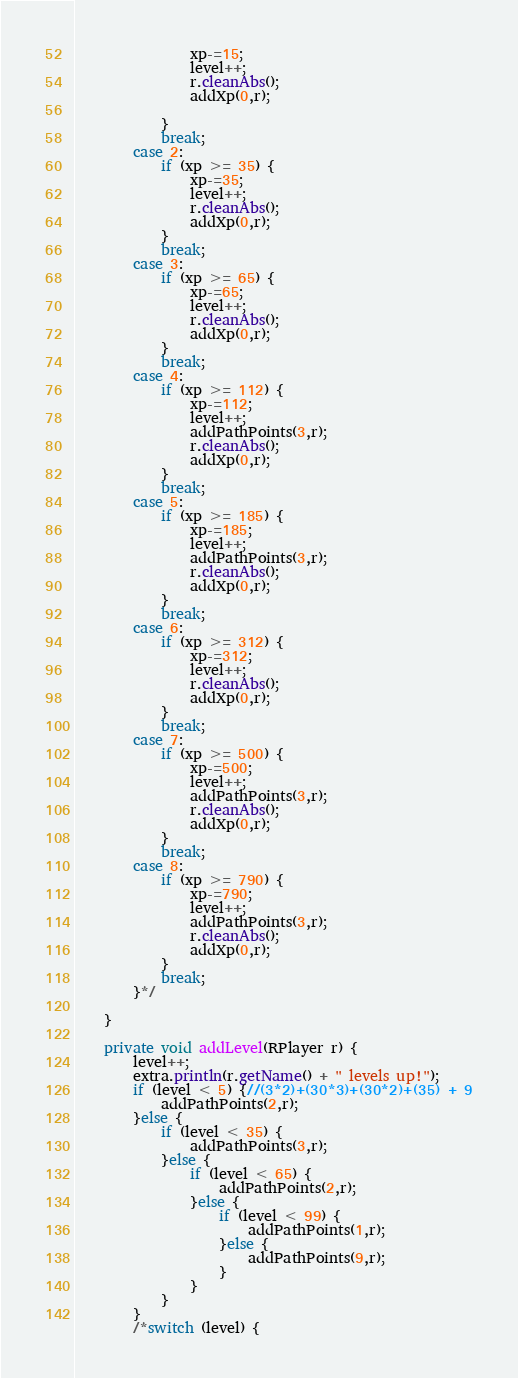<code> <loc_0><loc_0><loc_500><loc_500><_Java_>				xp-=15;
				level++;
				r.cleanAbs();
				addXp(0,r);
				
			}
			break;
		case 2:
			if (xp >= 35) {
				xp-=35;
				level++;
				r.cleanAbs();
				addXp(0,r);
			}
			break;
		case 3:
			if (xp >= 65) {
				xp-=65;
				level++;
				r.cleanAbs();
				addXp(0,r);
			}
			break;
		case 4:
			if (xp >= 112) {
				xp-=112;
				level++;
				addPathPoints(3,r);
				r.cleanAbs();
				addXp(0,r);
			}
			break;
		case 5:
			if (xp >= 185) {
				xp-=185;
				level++;
				addPathPoints(3,r);
				r.cleanAbs();
				addXp(0,r);
			}
			break;
		case 6:
			if (xp >= 312) {
				xp-=312;
				level++;
				r.cleanAbs();
				addXp(0,r);
			}
			break;
		case 7:
			if (xp >= 500) {
				xp-=500;
				level++;
				addPathPoints(3,r);
				r.cleanAbs();
				addXp(0,r);
			}
			break;
		case 8:
			if (xp >= 790) {
				xp-=790;
				level++;
				addPathPoints(3,r);
				r.cleanAbs();
				addXp(0,r);
			}
			break;
		}*/
		
	}
	
	private void addLevel(RPlayer r) {
		level++;
		extra.println(r.getName() + " levels up!");
		if (level < 5) {//(3*2)+(30*3)+(30*2)+(35) + 9
			addPathPoints(2,r);
		}else {
			if (level < 35) {
				addPathPoints(3,r);
			}else {
				if (level < 65) {
					addPathPoints(2,r);
				}else {
					if (level < 99) {
						addPathPoints(1,r);
					}else {
						addPathPoints(9,r);
					}
				}
			}
		}
		/*switch (level) {</code> 